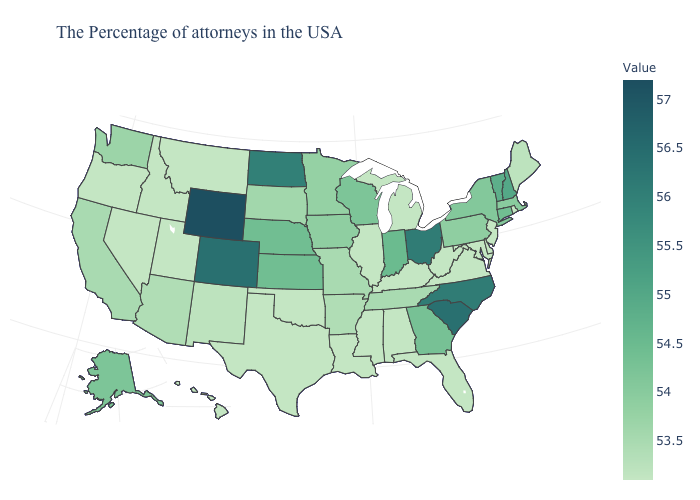Among the states that border Utah , does Wyoming have the highest value?
Give a very brief answer. Yes. Does the map have missing data?
Short answer required. No. Which states have the highest value in the USA?
Write a very short answer. Wyoming. Among the states that border Arizona , does Colorado have the lowest value?
Be succinct. No. Does the map have missing data?
Concise answer only. No. 